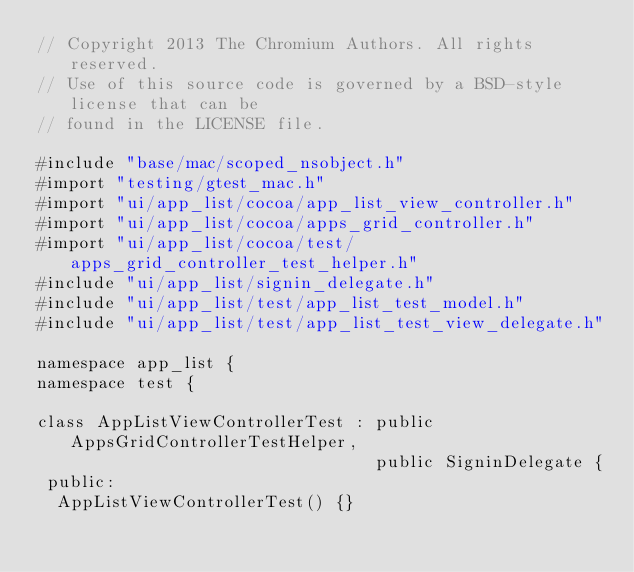Convert code to text. <code><loc_0><loc_0><loc_500><loc_500><_ObjectiveC_>// Copyright 2013 The Chromium Authors. All rights reserved.
// Use of this source code is governed by a BSD-style license that can be
// found in the LICENSE file.

#include "base/mac/scoped_nsobject.h"
#import "testing/gtest_mac.h"
#import "ui/app_list/cocoa/app_list_view_controller.h"
#import "ui/app_list/cocoa/apps_grid_controller.h"
#import "ui/app_list/cocoa/test/apps_grid_controller_test_helper.h"
#include "ui/app_list/signin_delegate.h"
#include "ui/app_list/test/app_list_test_model.h"
#include "ui/app_list/test/app_list_test_view_delegate.h"

namespace app_list {
namespace test {

class AppListViewControllerTest : public AppsGridControllerTestHelper,
                                  public SigninDelegate {
 public:
  AppListViewControllerTest() {}
</code> 